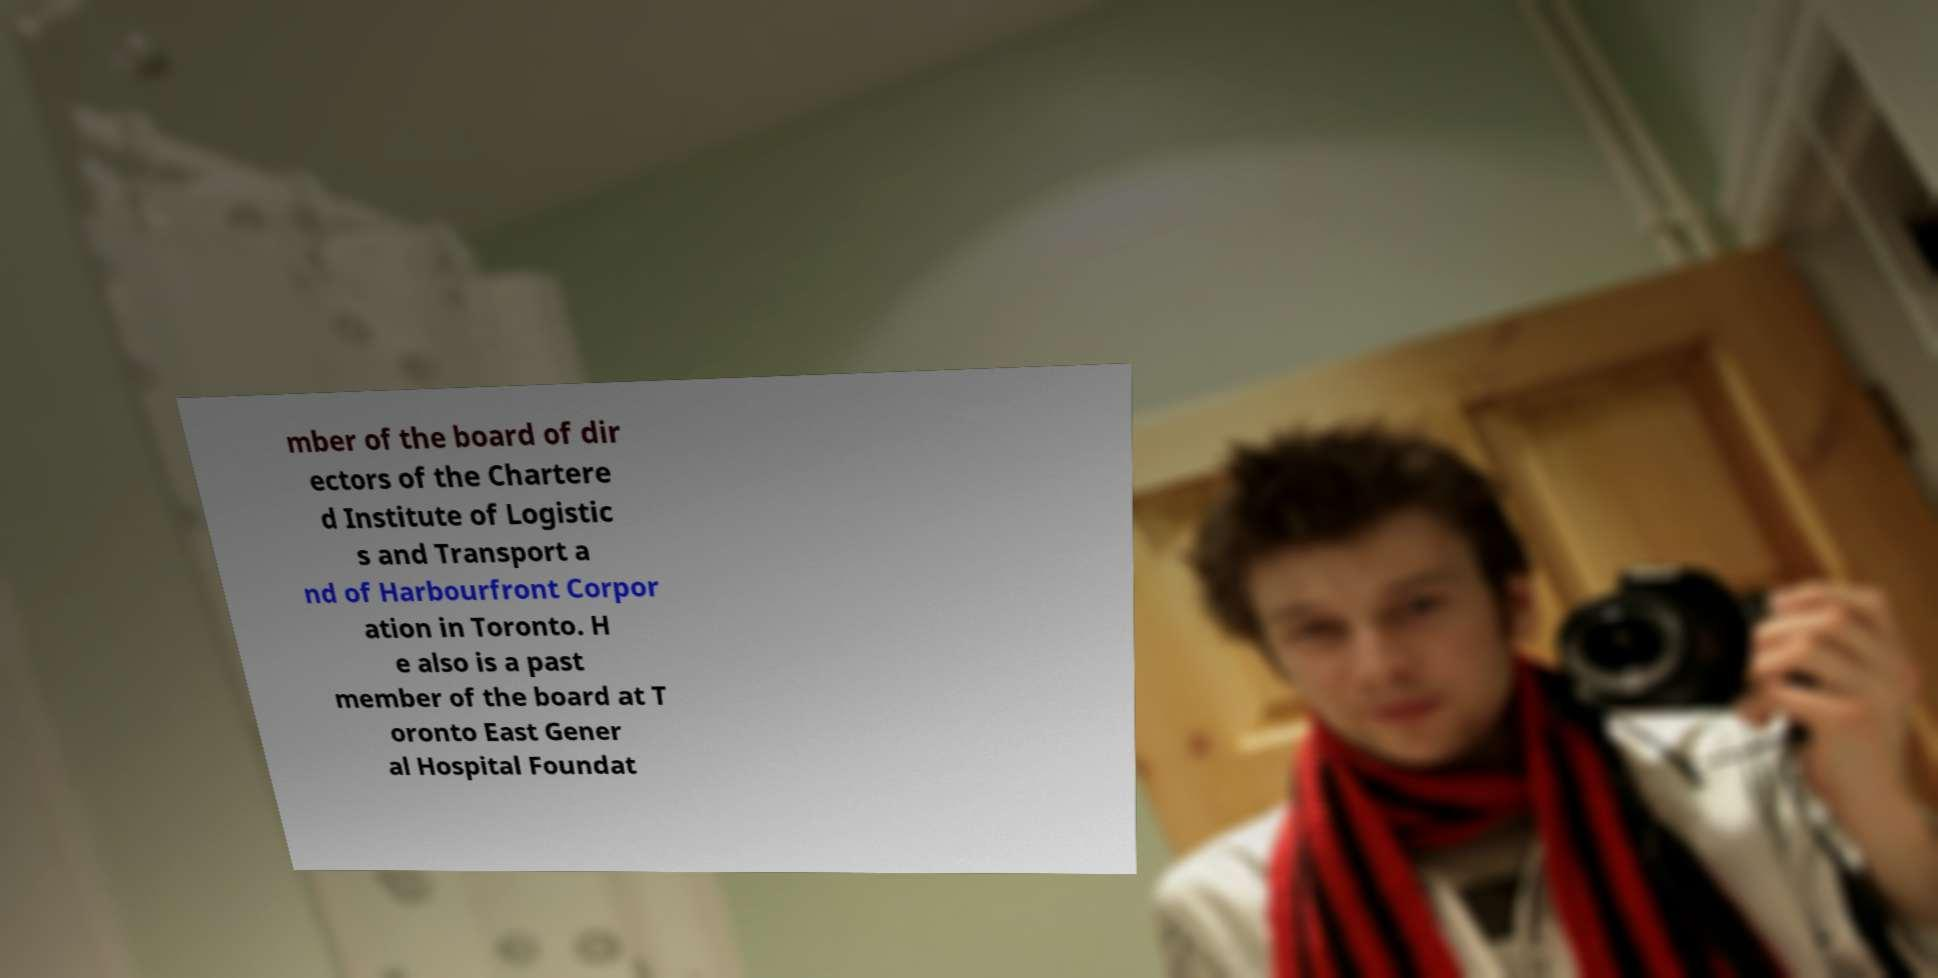Could you assist in decoding the text presented in this image and type it out clearly? mber of the board of dir ectors of the Chartere d Institute of Logistic s and Transport a nd of Harbourfront Corpor ation in Toronto. H e also is a past member of the board at T oronto East Gener al Hospital Foundat 